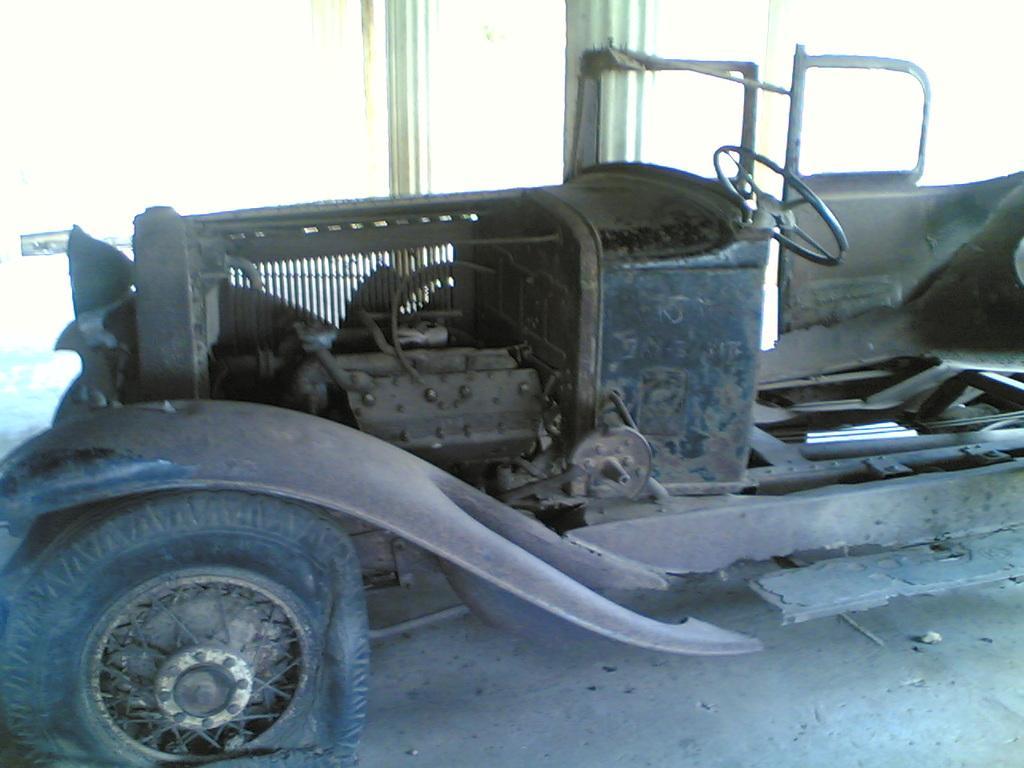Describe this image in one or two sentences. In this picture we can observe an old vehicle. This vehicle is in brown color. We can observe pillars here. This vehicle is parked on this floor. 